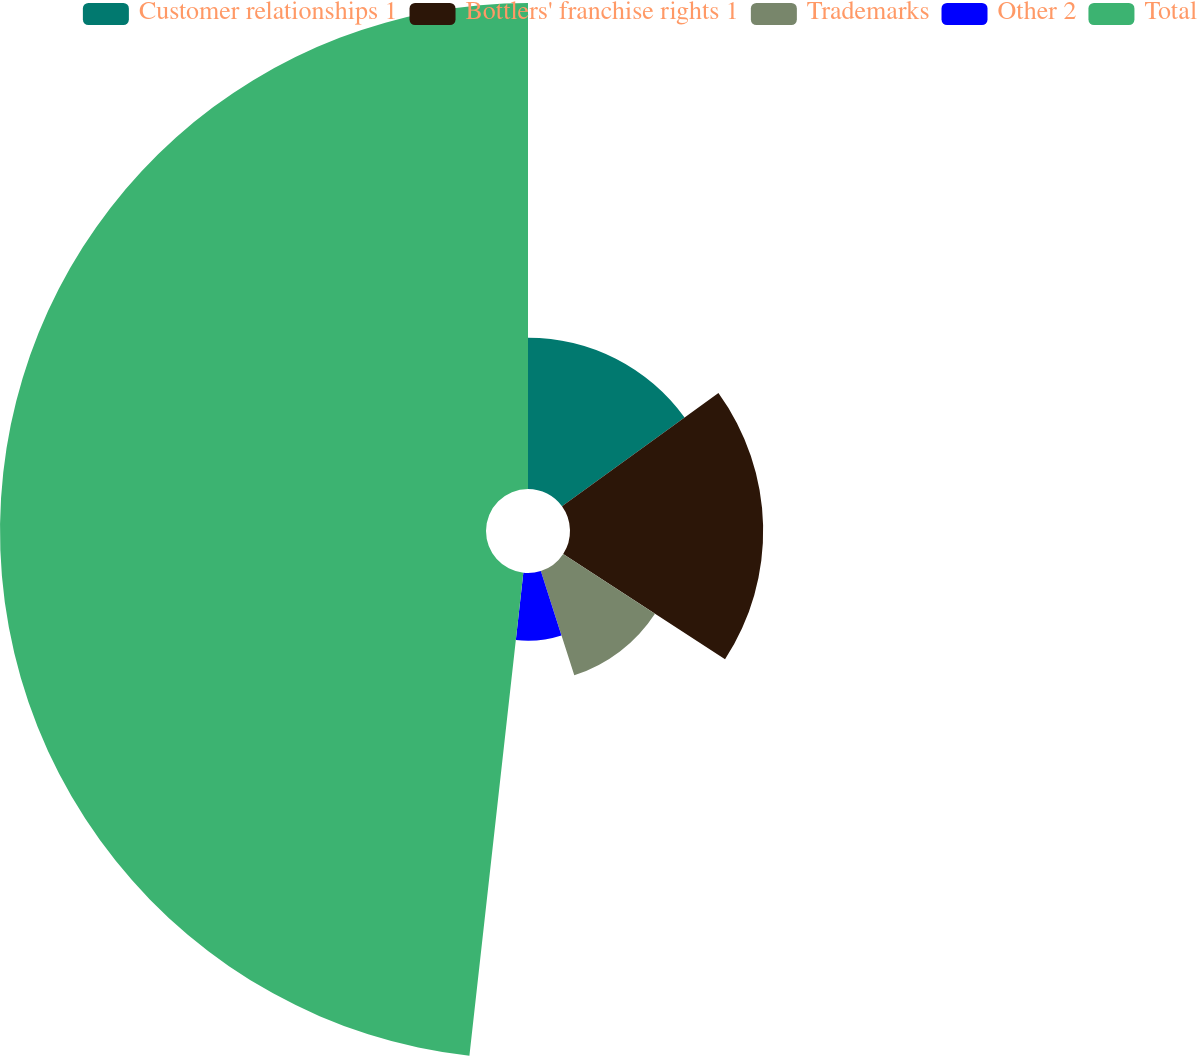Convert chart. <chart><loc_0><loc_0><loc_500><loc_500><pie_chart><fcel>Customer relationships 1<fcel>Bottlers' franchise rights 1<fcel>Trademarks<fcel>Other 2<fcel>Total<nl><fcel>15.02%<fcel>19.17%<fcel>10.87%<fcel>6.71%<fcel>48.23%<nl></chart> 